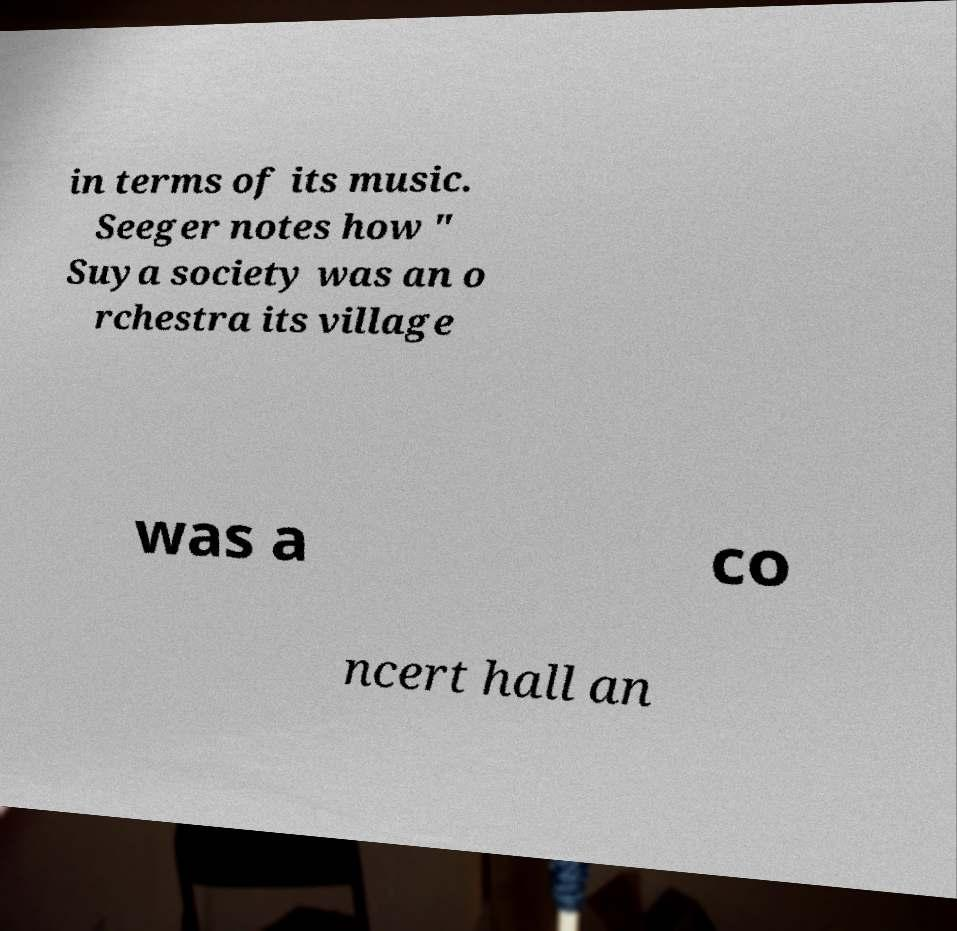Please identify and transcribe the text found in this image. in terms of its music. Seeger notes how " Suya society was an o rchestra its village was a co ncert hall an 